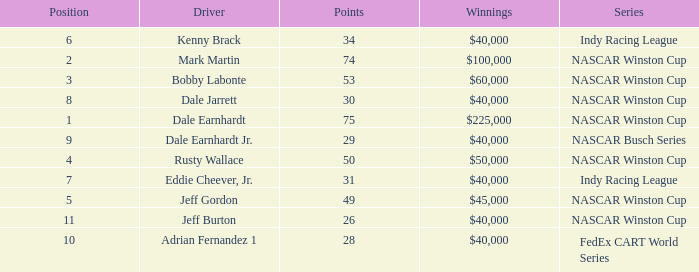In what position was the driver who won $60,000? 3.0. 